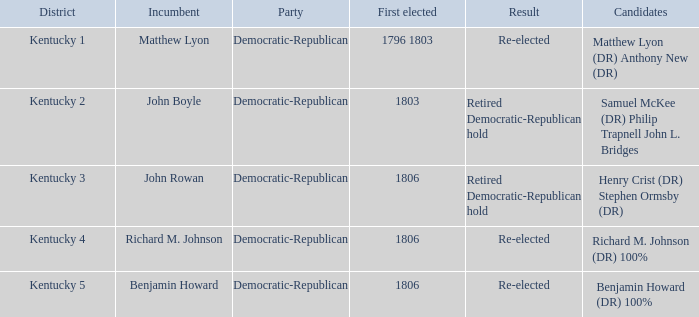Who was the inaugural elected official for kentucky 3? 1806.0. 